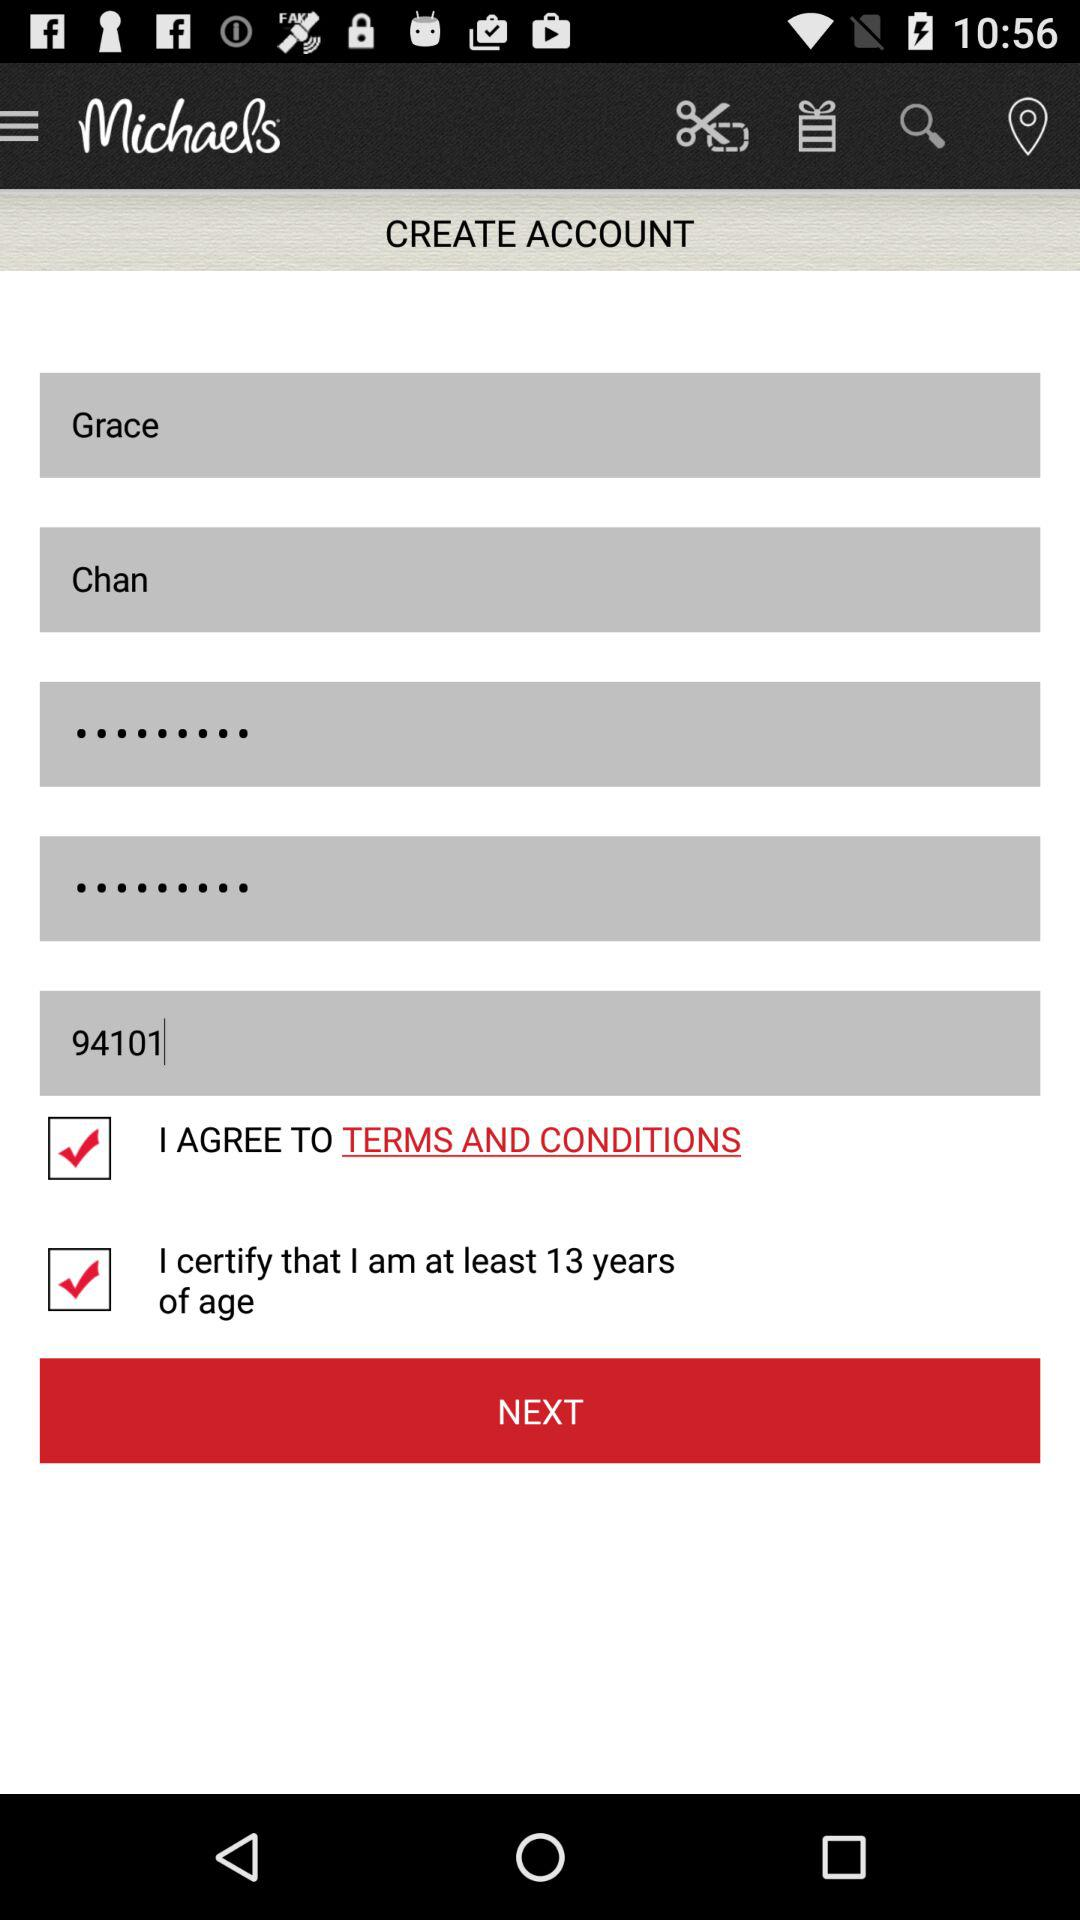What is the status of "I certify that I am at least 13 years of age"? The status is on. 